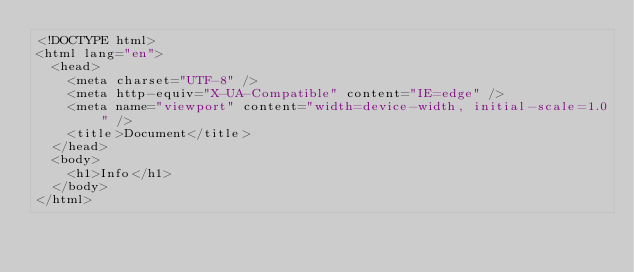<code> <loc_0><loc_0><loc_500><loc_500><_HTML_><!DOCTYPE html>
<html lang="en">
  <head>
    <meta charset="UTF-8" />
    <meta http-equiv="X-UA-Compatible" content="IE=edge" />
    <meta name="viewport" content="width=device-width, initial-scale=1.0" />
    <title>Document</title>
  </head>
  <body>
    <h1>Info</h1>
  </body>
</html>
</code> 